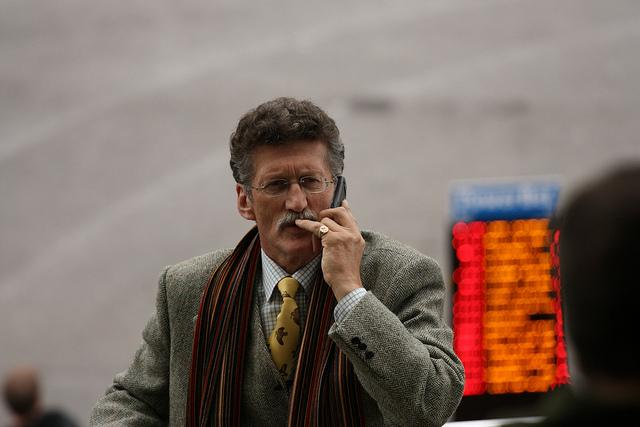What is the man with the mustache doing with the black object? talking 